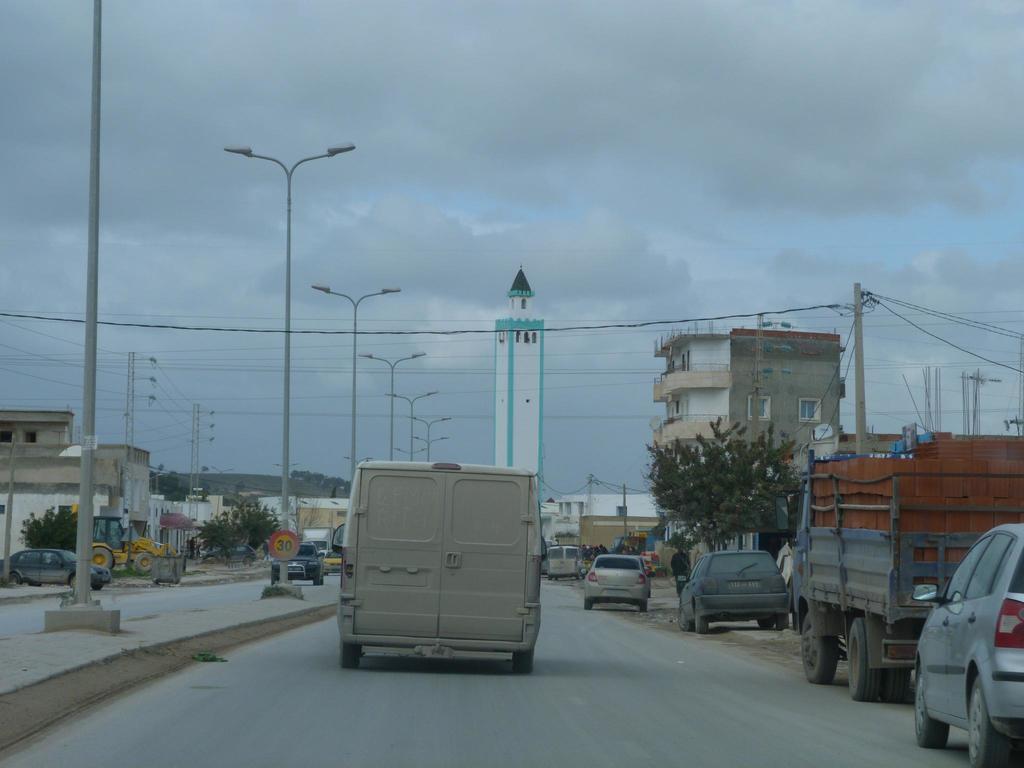Please provide a concise description of this image. In this image we can see some vehicles on the road and there are some buildings and we can see some street lights on the left side of the image. There are some trees and at the top we can see the sky with clouds. 